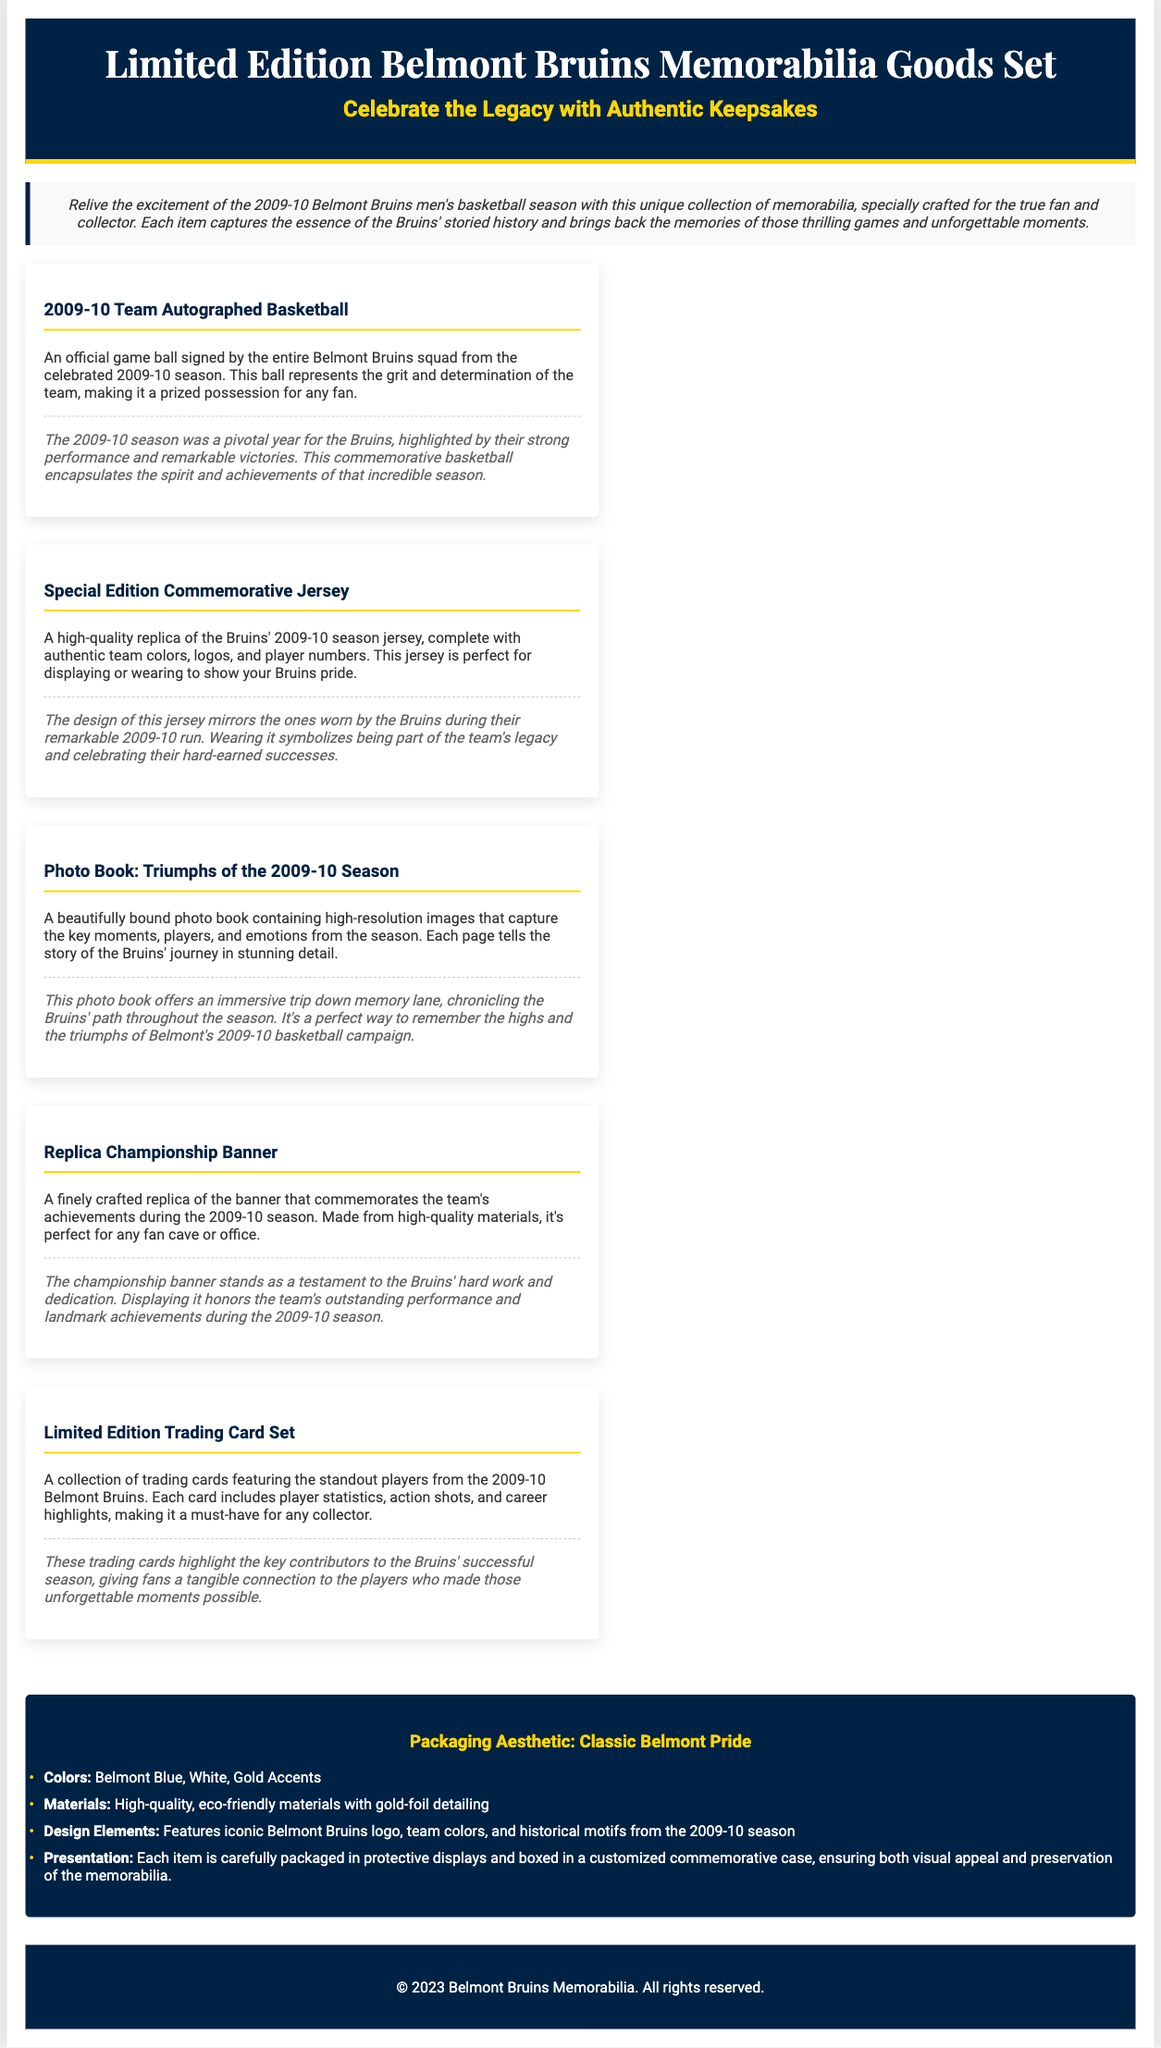What is the main theme of the memorabilia set? The theme revolves around celebrating the legacy of the Belmont Bruins basketball team, particularly the 2009-10 season, through authentic keepsakes.
Answer: Celebrating the Legacy How many items are included in the memorabilia set? The document lists a total of five distinct items included in the set.
Answer: Five What color is primarily used in the packaging? The primary color of the packaging mentioned is Belmont Blue.
Answer: Belmont Blue What type of material is used for packaging? High-quality, eco-friendly materials are specified for the packaging of the memorabilia goods.
Answer: Eco-friendly materials What is the title of the photo book in the set? The title of the photo book included in the memorabilia set is "Triumphs of the 2009-10 Season."
Answer: Triumphs of the 2009-10 Season Which item represents the entire team's autographs? The item that represents the entire team's autographs is the "2009-10 Team Autographed Basketball."
Answer: 2009-10 Team Autographed Basketball What type of jersey is included in the set? A high-quality replica of the Bruins' 2009-10 season jersey is included in the memorabilia goods.
Answer: Replica jersey What design element is featured on the packaging? The packaging features the iconic Belmont Bruins logo among other design elements.
Answer: Bruins logo What special feature enhances the packaging's visual appeal? Gold-foil detailing enhances the visual appeal of the packaging.
Answer: Gold-foil detailing 